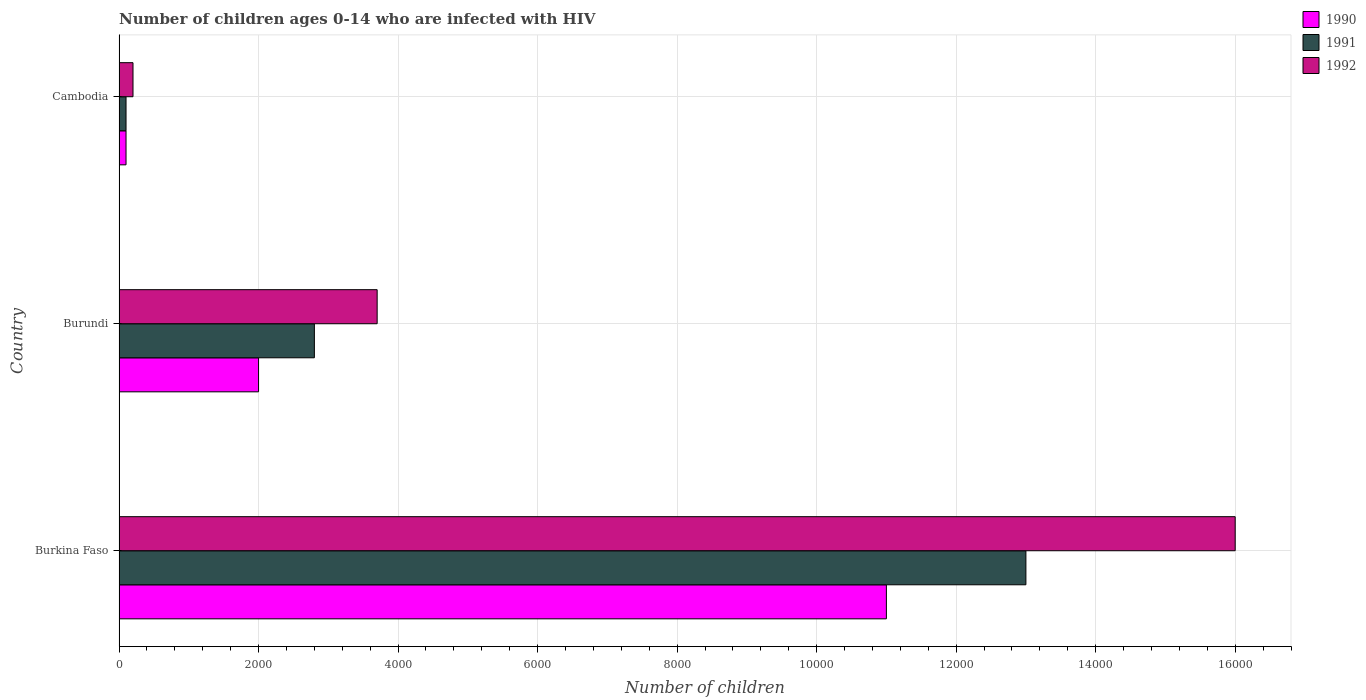How many different coloured bars are there?
Provide a succinct answer. 3. How many groups of bars are there?
Provide a succinct answer. 3. What is the label of the 2nd group of bars from the top?
Provide a succinct answer. Burundi. In how many cases, is the number of bars for a given country not equal to the number of legend labels?
Provide a short and direct response. 0. What is the number of HIV infected children in 1992 in Cambodia?
Offer a very short reply. 200. Across all countries, what is the maximum number of HIV infected children in 1990?
Offer a very short reply. 1.10e+04. Across all countries, what is the minimum number of HIV infected children in 1991?
Keep it short and to the point. 100. In which country was the number of HIV infected children in 1990 maximum?
Your answer should be compact. Burkina Faso. In which country was the number of HIV infected children in 1991 minimum?
Your response must be concise. Cambodia. What is the total number of HIV infected children in 1990 in the graph?
Provide a short and direct response. 1.31e+04. What is the difference between the number of HIV infected children in 1991 in Burundi and that in Cambodia?
Offer a terse response. 2700. What is the difference between the number of HIV infected children in 1992 in Burkina Faso and the number of HIV infected children in 1991 in Burundi?
Offer a terse response. 1.32e+04. What is the average number of HIV infected children in 1991 per country?
Offer a terse response. 5300. What is the difference between the number of HIV infected children in 1992 and number of HIV infected children in 1991 in Cambodia?
Ensure brevity in your answer.  100. In how many countries, is the number of HIV infected children in 1990 greater than 4400 ?
Provide a succinct answer. 1. What is the ratio of the number of HIV infected children in 1991 in Burkina Faso to that in Cambodia?
Your answer should be compact. 130. What is the difference between the highest and the second highest number of HIV infected children in 1992?
Your answer should be very brief. 1.23e+04. What is the difference between the highest and the lowest number of HIV infected children in 1991?
Ensure brevity in your answer.  1.29e+04. In how many countries, is the number of HIV infected children in 1992 greater than the average number of HIV infected children in 1992 taken over all countries?
Offer a very short reply. 1. Is it the case that in every country, the sum of the number of HIV infected children in 1990 and number of HIV infected children in 1991 is greater than the number of HIV infected children in 1992?
Keep it short and to the point. No. Are all the bars in the graph horizontal?
Ensure brevity in your answer.  Yes. How many countries are there in the graph?
Offer a very short reply. 3. What is the difference between two consecutive major ticks on the X-axis?
Ensure brevity in your answer.  2000. Does the graph contain any zero values?
Keep it short and to the point. No. Does the graph contain grids?
Ensure brevity in your answer.  Yes. Where does the legend appear in the graph?
Make the answer very short. Top right. How many legend labels are there?
Your answer should be very brief. 3. How are the legend labels stacked?
Keep it short and to the point. Vertical. What is the title of the graph?
Offer a very short reply. Number of children ages 0-14 who are infected with HIV. Does "1995" appear as one of the legend labels in the graph?
Provide a short and direct response. No. What is the label or title of the X-axis?
Keep it short and to the point. Number of children. What is the label or title of the Y-axis?
Provide a short and direct response. Country. What is the Number of children of 1990 in Burkina Faso?
Ensure brevity in your answer.  1.10e+04. What is the Number of children of 1991 in Burkina Faso?
Your answer should be compact. 1.30e+04. What is the Number of children in 1992 in Burkina Faso?
Give a very brief answer. 1.60e+04. What is the Number of children in 1990 in Burundi?
Your answer should be compact. 2000. What is the Number of children of 1991 in Burundi?
Make the answer very short. 2800. What is the Number of children of 1992 in Burundi?
Your answer should be very brief. 3700. What is the Number of children in 1990 in Cambodia?
Provide a short and direct response. 100. What is the Number of children in 1991 in Cambodia?
Make the answer very short. 100. Across all countries, what is the maximum Number of children of 1990?
Offer a very short reply. 1.10e+04. Across all countries, what is the maximum Number of children of 1991?
Ensure brevity in your answer.  1.30e+04. Across all countries, what is the maximum Number of children in 1992?
Your response must be concise. 1.60e+04. What is the total Number of children in 1990 in the graph?
Make the answer very short. 1.31e+04. What is the total Number of children of 1991 in the graph?
Offer a very short reply. 1.59e+04. What is the total Number of children of 1992 in the graph?
Offer a terse response. 1.99e+04. What is the difference between the Number of children of 1990 in Burkina Faso and that in Burundi?
Ensure brevity in your answer.  9000. What is the difference between the Number of children in 1991 in Burkina Faso and that in Burundi?
Make the answer very short. 1.02e+04. What is the difference between the Number of children in 1992 in Burkina Faso and that in Burundi?
Ensure brevity in your answer.  1.23e+04. What is the difference between the Number of children in 1990 in Burkina Faso and that in Cambodia?
Make the answer very short. 1.09e+04. What is the difference between the Number of children in 1991 in Burkina Faso and that in Cambodia?
Provide a succinct answer. 1.29e+04. What is the difference between the Number of children in 1992 in Burkina Faso and that in Cambodia?
Your answer should be very brief. 1.58e+04. What is the difference between the Number of children in 1990 in Burundi and that in Cambodia?
Give a very brief answer. 1900. What is the difference between the Number of children in 1991 in Burundi and that in Cambodia?
Make the answer very short. 2700. What is the difference between the Number of children in 1992 in Burundi and that in Cambodia?
Your answer should be compact. 3500. What is the difference between the Number of children of 1990 in Burkina Faso and the Number of children of 1991 in Burundi?
Provide a succinct answer. 8200. What is the difference between the Number of children in 1990 in Burkina Faso and the Number of children in 1992 in Burundi?
Provide a short and direct response. 7300. What is the difference between the Number of children of 1991 in Burkina Faso and the Number of children of 1992 in Burundi?
Give a very brief answer. 9300. What is the difference between the Number of children of 1990 in Burkina Faso and the Number of children of 1991 in Cambodia?
Provide a succinct answer. 1.09e+04. What is the difference between the Number of children of 1990 in Burkina Faso and the Number of children of 1992 in Cambodia?
Your answer should be compact. 1.08e+04. What is the difference between the Number of children of 1991 in Burkina Faso and the Number of children of 1992 in Cambodia?
Offer a very short reply. 1.28e+04. What is the difference between the Number of children of 1990 in Burundi and the Number of children of 1991 in Cambodia?
Your response must be concise. 1900. What is the difference between the Number of children in 1990 in Burundi and the Number of children in 1992 in Cambodia?
Your answer should be very brief. 1800. What is the difference between the Number of children of 1991 in Burundi and the Number of children of 1992 in Cambodia?
Offer a very short reply. 2600. What is the average Number of children of 1990 per country?
Make the answer very short. 4366.67. What is the average Number of children of 1991 per country?
Offer a terse response. 5300. What is the average Number of children of 1992 per country?
Make the answer very short. 6633.33. What is the difference between the Number of children of 1990 and Number of children of 1991 in Burkina Faso?
Offer a terse response. -2000. What is the difference between the Number of children of 1990 and Number of children of 1992 in Burkina Faso?
Give a very brief answer. -5000. What is the difference between the Number of children of 1991 and Number of children of 1992 in Burkina Faso?
Your response must be concise. -3000. What is the difference between the Number of children of 1990 and Number of children of 1991 in Burundi?
Offer a very short reply. -800. What is the difference between the Number of children of 1990 and Number of children of 1992 in Burundi?
Provide a short and direct response. -1700. What is the difference between the Number of children of 1991 and Number of children of 1992 in Burundi?
Give a very brief answer. -900. What is the difference between the Number of children of 1990 and Number of children of 1991 in Cambodia?
Give a very brief answer. 0. What is the difference between the Number of children in 1990 and Number of children in 1992 in Cambodia?
Ensure brevity in your answer.  -100. What is the difference between the Number of children of 1991 and Number of children of 1992 in Cambodia?
Your answer should be very brief. -100. What is the ratio of the Number of children in 1991 in Burkina Faso to that in Burundi?
Your response must be concise. 4.64. What is the ratio of the Number of children in 1992 in Burkina Faso to that in Burundi?
Offer a terse response. 4.32. What is the ratio of the Number of children of 1990 in Burkina Faso to that in Cambodia?
Offer a very short reply. 110. What is the ratio of the Number of children in 1991 in Burkina Faso to that in Cambodia?
Keep it short and to the point. 130. What is the ratio of the Number of children in 1990 in Burundi to that in Cambodia?
Provide a short and direct response. 20. What is the ratio of the Number of children of 1992 in Burundi to that in Cambodia?
Provide a succinct answer. 18.5. What is the difference between the highest and the second highest Number of children in 1990?
Ensure brevity in your answer.  9000. What is the difference between the highest and the second highest Number of children in 1991?
Give a very brief answer. 1.02e+04. What is the difference between the highest and the second highest Number of children of 1992?
Offer a very short reply. 1.23e+04. What is the difference between the highest and the lowest Number of children of 1990?
Provide a short and direct response. 1.09e+04. What is the difference between the highest and the lowest Number of children of 1991?
Keep it short and to the point. 1.29e+04. What is the difference between the highest and the lowest Number of children in 1992?
Your answer should be very brief. 1.58e+04. 